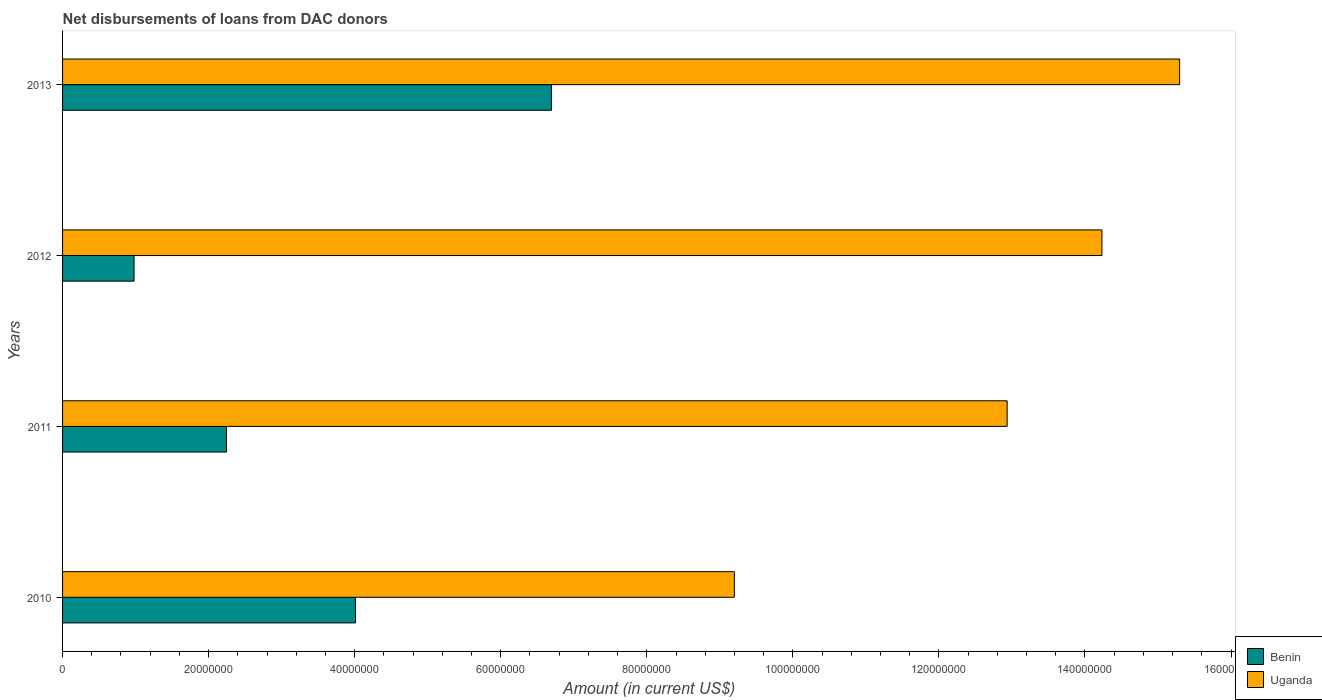How many different coloured bars are there?
Provide a short and direct response. 2. Are the number of bars on each tick of the Y-axis equal?
Your answer should be compact. Yes. How many bars are there on the 2nd tick from the bottom?
Your answer should be very brief. 2. What is the label of the 2nd group of bars from the top?
Keep it short and to the point. 2012. What is the amount of loans disbursed in Benin in 2013?
Provide a succinct answer. 6.69e+07. Across all years, what is the maximum amount of loans disbursed in Uganda?
Provide a succinct answer. 1.53e+08. Across all years, what is the minimum amount of loans disbursed in Uganda?
Keep it short and to the point. 9.20e+07. What is the total amount of loans disbursed in Benin in the graph?
Keep it short and to the point. 1.39e+08. What is the difference between the amount of loans disbursed in Uganda in 2010 and that in 2011?
Offer a terse response. -3.74e+07. What is the difference between the amount of loans disbursed in Uganda in 2010 and the amount of loans disbursed in Benin in 2013?
Offer a very short reply. 2.50e+07. What is the average amount of loans disbursed in Uganda per year?
Offer a very short reply. 1.29e+08. In the year 2013, what is the difference between the amount of loans disbursed in Benin and amount of loans disbursed in Uganda?
Your response must be concise. -8.60e+07. What is the ratio of the amount of loans disbursed in Benin in 2011 to that in 2012?
Your answer should be very brief. 2.29. What is the difference between the highest and the second highest amount of loans disbursed in Benin?
Your answer should be compact. 2.68e+07. What is the difference between the highest and the lowest amount of loans disbursed in Uganda?
Ensure brevity in your answer.  6.10e+07. What does the 2nd bar from the top in 2011 represents?
Offer a very short reply. Benin. What does the 2nd bar from the bottom in 2013 represents?
Offer a very short reply. Uganda. How many bars are there?
Your answer should be very brief. 8. Are all the bars in the graph horizontal?
Ensure brevity in your answer.  Yes. How many years are there in the graph?
Your answer should be very brief. 4. How many legend labels are there?
Your answer should be very brief. 2. How are the legend labels stacked?
Your answer should be compact. Vertical. What is the title of the graph?
Make the answer very short. Net disbursements of loans from DAC donors. Does "Malawi" appear as one of the legend labels in the graph?
Provide a succinct answer. No. What is the Amount (in current US$) of Benin in 2010?
Offer a very short reply. 4.01e+07. What is the Amount (in current US$) in Uganda in 2010?
Make the answer very short. 9.20e+07. What is the Amount (in current US$) in Benin in 2011?
Give a very brief answer. 2.25e+07. What is the Amount (in current US$) of Uganda in 2011?
Offer a very short reply. 1.29e+08. What is the Amount (in current US$) in Benin in 2012?
Keep it short and to the point. 9.79e+06. What is the Amount (in current US$) in Uganda in 2012?
Ensure brevity in your answer.  1.42e+08. What is the Amount (in current US$) of Benin in 2013?
Provide a short and direct response. 6.69e+07. What is the Amount (in current US$) of Uganda in 2013?
Give a very brief answer. 1.53e+08. Across all years, what is the maximum Amount (in current US$) of Benin?
Your answer should be very brief. 6.69e+07. Across all years, what is the maximum Amount (in current US$) of Uganda?
Provide a succinct answer. 1.53e+08. Across all years, what is the minimum Amount (in current US$) of Benin?
Make the answer very short. 9.79e+06. Across all years, what is the minimum Amount (in current US$) in Uganda?
Give a very brief answer. 9.20e+07. What is the total Amount (in current US$) in Benin in the graph?
Provide a succinct answer. 1.39e+08. What is the total Amount (in current US$) in Uganda in the graph?
Your response must be concise. 5.17e+08. What is the difference between the Amount (in current US$) in Benin in 2010 and that in 2011?
Your answer should be very brief. 1.77e+07. What is the difference between the Amount (in current US$) in Uganda in 2010 and that in 2011?
Offer a terse response. -3.74e+07. What is the difference between the Amount (in current US$) of Benin in 2010 and that in 2012?
Provide a succinct answer. 3.03e+07. What is the difference between the Amount (in current US$) of Uganda in 2010 and that in 2012?
Your answer should be very brief. -5.03e+07. What is the difference between the Amount (in current US$) in Benin in 2010 and that in 2013?
Offer a terse response. -2.68e+07. What is the difference between the Amount (in current US$) in Uganda in 2010 and that in 2013?
Offer a very short reply. -6.10e+07. What is the difference between the Amount (in current US$) in Benin in 2011 and that in 2012?
Your response must be concise. 1.27e+07. What is the difference between the Amount (in current US$) in Uganda in 2011 and that in 2012?
Give a very brief answer. -1.30e+07. What is the difference between the Amount (in current US$) in Benin in 2011 and that in 2013?
Ensure brevity in your answer.  -4.45e+07. What is the difference between the Amount (in current US$) in Uganda in 2011 and that in 2013?
Offer a very short reply. -2.36e+07. What is the difference between the Amount (in current US$) of Benin in 2012 and that in 2013?
Give a very brief answer. -5.72e+07. What is the difference between the Amount (in current US$) in Uganda in 2012 and that in 2013?
Keep it short and to the point. -1.06e+07. What is the difference between the Amount (in current US$) of Benin in 2010 and the Amount (in current US$) of Uganda in 2011?
Offer a very short reply. -8.92e+07. What is the difference between the Amount (in current US$) of Benin in 2010 and the Amount (in current US$) of Uganda in 2012?
Offer a terse response. -1.02e+08. What is the difference between the Amount (in current US$) of Benin in 2010 and the Amount (in current US$) of Uganda in 2013?
Your answer should be very brief. -1.13e+08. What is the difference between the Amount (in current US$) of Benin in 2011 and the Amount (in current US$) of Uganda in 2012?
Give a very brief answer. -1.20e+08. What is the difference between the Amount (in current US$) of Benin in 2011 and the Amount (in current US$) of Uganda in 2013?
Ensure brevity in your answer.  -1.31e+08. What is the difference between the Amount (in current US$) in Benin in 2012 and the Amount (in current US$) in Uganda in 2013?
Make the answer very short. -1.43e+08. What is the average Amount (in current US$) of Benin per year?
Provide a short and direct response. 3.48e+07. What is the average Amount (in current US$) of Uganda per year?
Ensure brevity in your answer.  1.29e+08. In the year 2010, what is the difference between the Amount (in current US$) of Benin and Amount (in current US$) of Uganda?
Keep it short and to the point. -5.19e+07. In the year 2011, what is the difference between the Amount (in current US$) of Benin and Amount (in current US$) of Uganda?
Make the answer very short. -1.07e+08. In the year 2012, what is the difference between the Amount (in current US$) in Benin and Amount (in current US$) in Uganda?
Ensure brevity in your answer.  -1.33e+08. In the year 2013, what is the difference between the Amount (in current US$) in Benin and Amount (in current US$) in Uganda?
Give a very brief answer. -8.60e+07. What is the ratio of the Amount (in current US$) of Benin in 2010 to that in 2011?
Make the answer very short. 1.79. What is the ratio of the Amount (in current US$) in Uganda in 2010 to that in 2011?
Make the answer very short. 0.71. What is the ratio of the Amount (in current US$) in Benin in 2010 to that in 2012?
Give a very brief answer. 4.1. What is the ratio of the Amount (in current US$) in Uganda in 2010 to that in 2012?
Make the answer very short. 0.65. What is the ratio of the Amount (in current US$) of Benin in 2010 to that in 2013?
Ensure brevity in your answer.  0.6. What is the ratio of the Amount (in current US$) in Uganda in 2010 to that in 2013?
Give a very brief answer. 0.6. What is the ratio of the Amount (in current US$) of Benin in 2011 to that in 2012?
Offer a terse response. 2.29. What is the ratio of the Amount (in current US$) of Uganda in 2011 to that in 2012?
Give a very brief answer. 0.91. What is the ratio of the Amount (in current US$) in Benin in 2011 to that in 2013?
Your answer should be very brief. 0.34. What is the ratio of the Amount (in current US$) in Uganda in 2011 to that in 2013?
Your response must be concise. 0.85. What is the ratio of the Amount (in current US$) of Benin in 2012 to that in 2013?
Make the answer very short. 0.15. What is the ratio of the Amount (in current US$) in Uganda in 2012 to that in 2013?
Offer a very short reply. 0.93. What is the difference between the highest and the second highest Amount (in current US$) in Benin?
Ensure brevity in your answer.  2.68e+07. What is the difference between the highest and the second highest Amount (in current US$) of Uganda?
Give a very brief answer. 1.06e+07. What is the difference between the highest and the lowest Amount (in current US$) in Benin?
Your answer should be compact. 5.72e+07. What is the difference between the highest and the lowest Amount (in current US$) in Uganda?
Offer a terse response. 6.10e+07. 